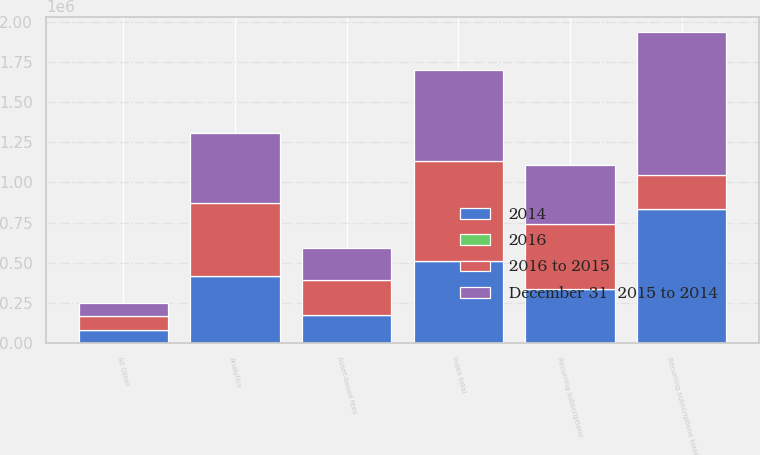<chart> <loc_0><loc_0><loc_500><loc_500><stacked_bar_chart><ecel><fcel>Recurring subscriptions<fcel>Asset-based fees<fcel>Index total<fcel>Analytics<fcel>All Other<fcel>Recurring subscriptions total<nl><fcel>2016 to 2015<fcel>406729<fcel>216982<fcel>623711<fcel>451533<fcel>88074<fcel>216982<nl><fcel>December 31  2015 to 2014<fcel>368855<fcel>201047<fcel>569902<fcel>436671<fcel>82677<fcel>888203<nl><fcel>2014<fcel>335277<fcel>174558<fcel>509835<fcel>417677<fcel>79213<fcel>832167<nl><fcel>2016<fcel>10.3<fcel>7.9<fcel>9.4<fcel>3.4<fcel>6.5<fcel>6.5<nl></chart> 